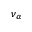<formula> <loc_0><loc_0><loc_500><loc_500>\nu _ { \alpha }</formula> 